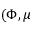Convert formula to latex. <formula><loc_0><loc_0><loc_500><loc_500>( \Phi , \mu</formula> 